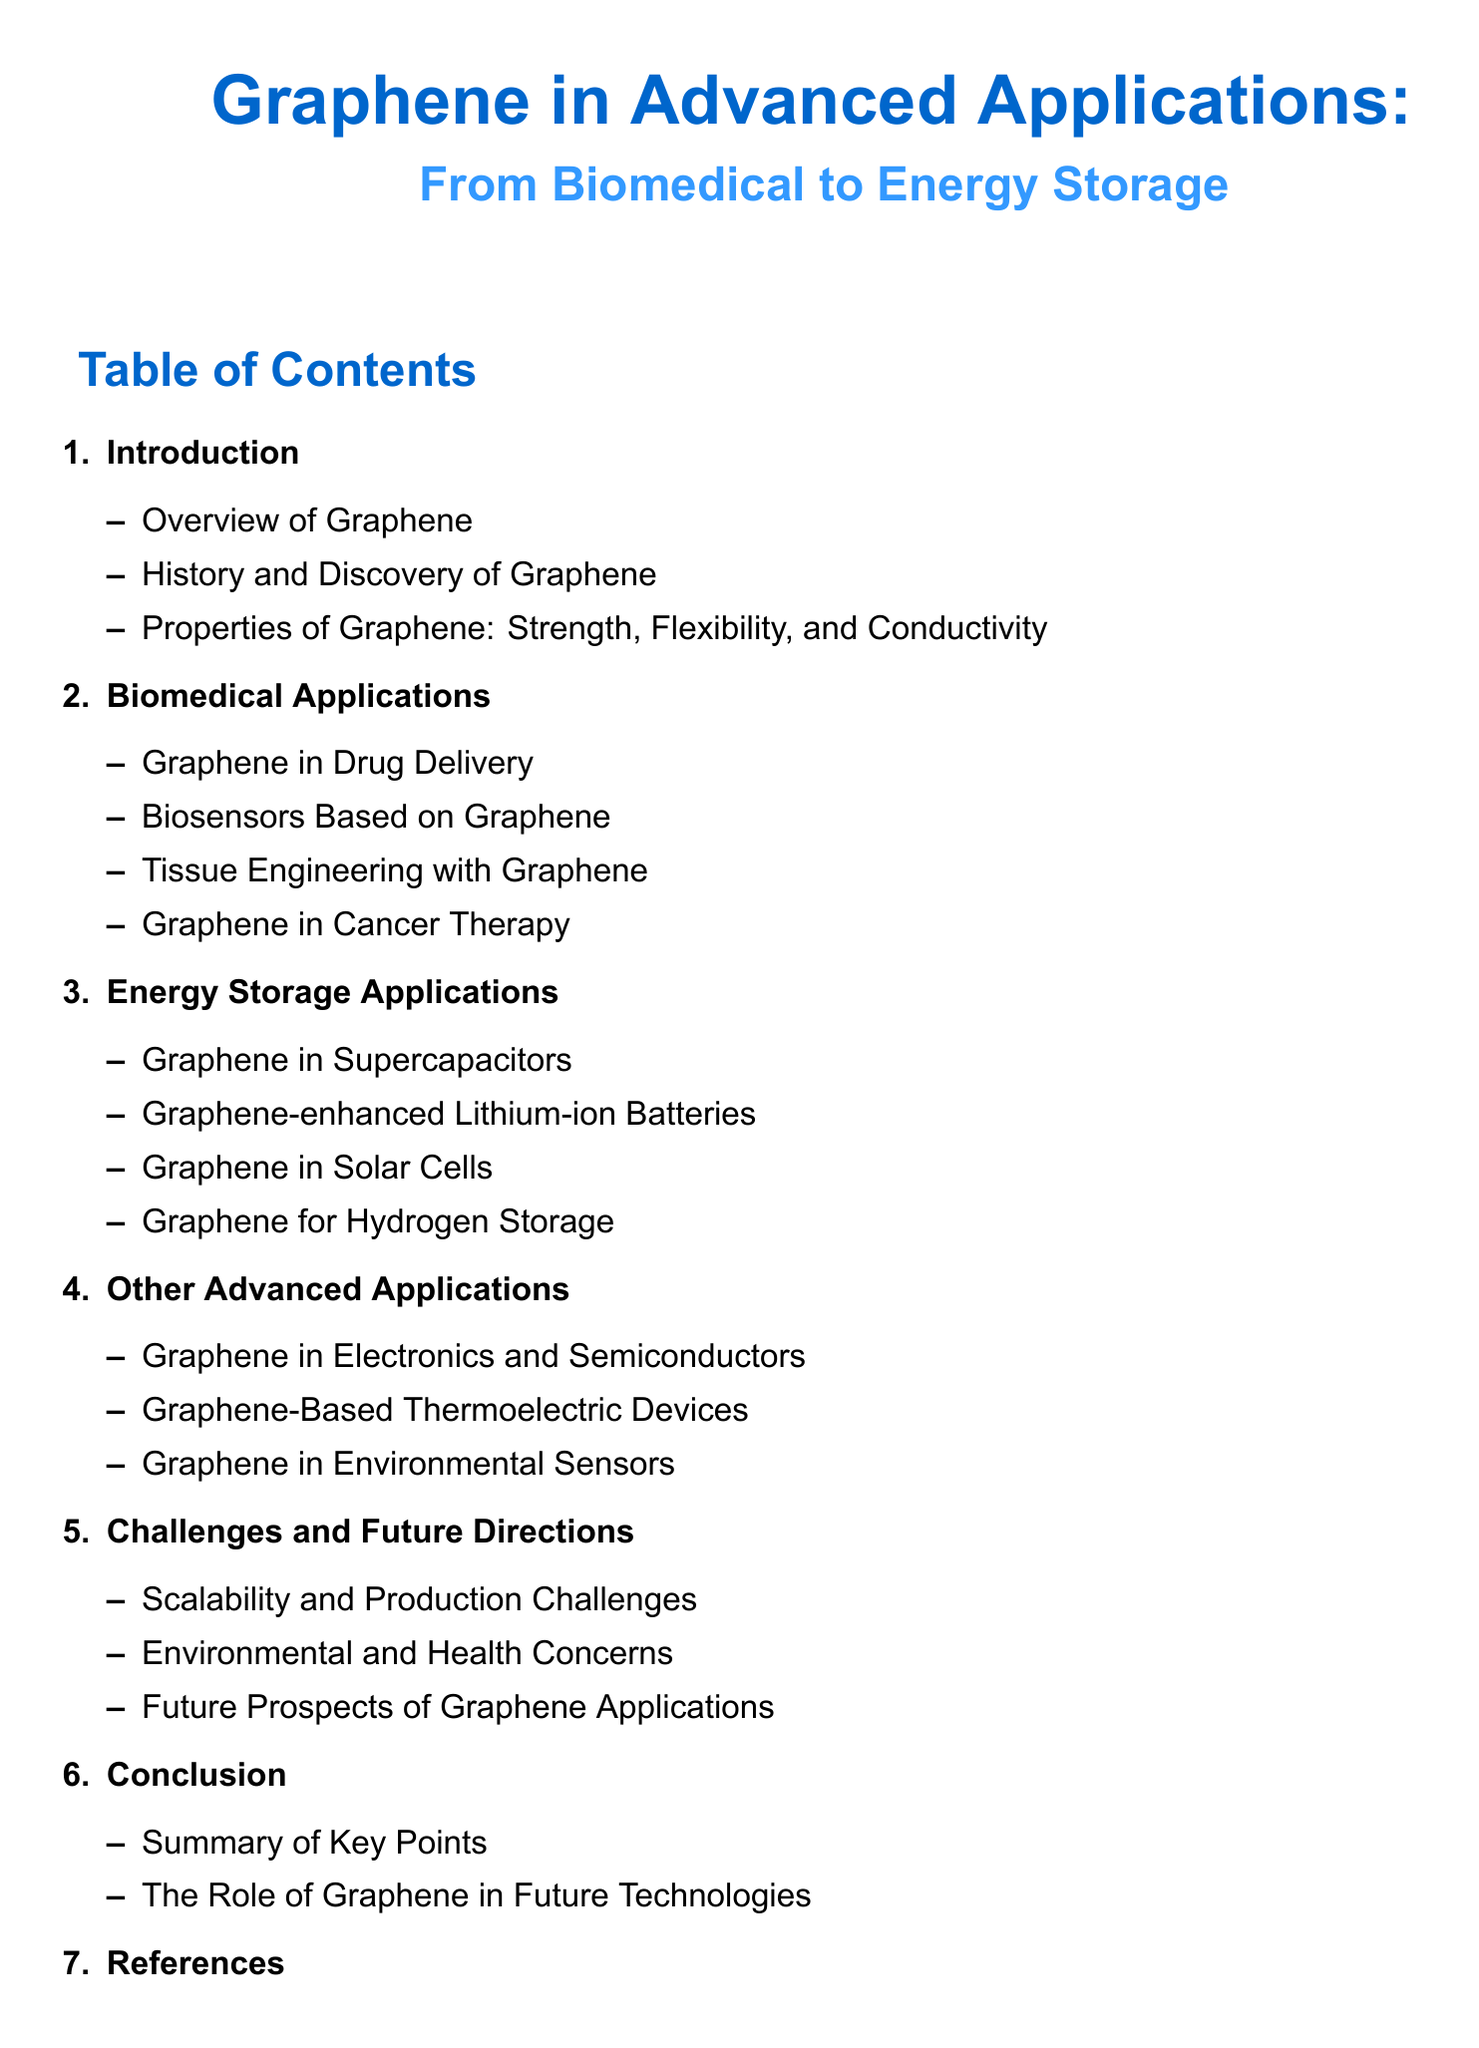What is the main topic of the document? The document focuses on the applications of graphene in various advanced fields, highlighting its uses from biomedical to energy storage.
Answer: Graphene in Advanced Applications: From Biomedical to Energy Storage How many sections are there in the Table of Contents? The Table of Contents lists a total of six main sections.
Answer: 6 What application of graphene is related to combating cancer? This section discusses how graphene can be utilized in treatments for cancer through various methodologies.
Answer: Graphene in Cancer Therapy Which section discusses graphene in energy storage? This section includes various applications of graphene specifically related to energy storage technologies.
Answer: Energy Storage Applications What is mentioned as a challenge in the future directions of graphene applications? This challenge relates to the logistics and sustainability of producing graphene at a large scale.
Answer: Scalability and Production Challenges Which specific application involves graphene in electronics? This refers to how graphene can be integrated into electronic devices and semiconductor technologies.
Answer: Graphene in Electronics and Semiconductors What is the last item listed in the Table of Contents? This item provides sources and references used throughout the document.
Answer: References Which biomedical application involves the use of graphene for monitoring health? This section highlights how graphene can be employed to develop sensitive health monitoring devices.
Answer: Biosensors Based on Graphene 